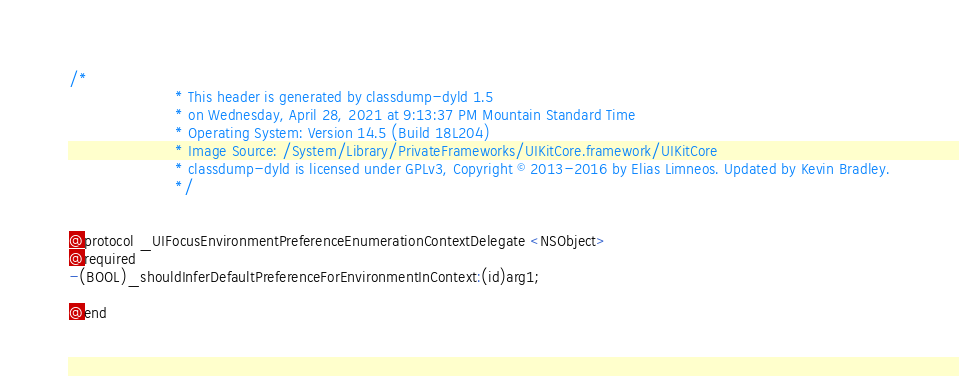<code> <loc_0><loc_0><loc_500><loc_500><_C_>/*
                       * This header is generated by classdump-dyld 1.5
                       * on Wednesday, April 28, 2021 at 9:13:37 PM Mountain Standard Time
                       * Operating System: Version 14.5 (Build 18L204)
                       * Image Source: /System/Library/PrivateFrameworks/UIKitCore.framework/UIKitCore
                       * classdump-dyld is licensed under GPLv3, Copyright © 2013-2016 by Elias Limneos. Updated by Kevin Bradley.
                       */


@protocol _UIFocusEnvironmentPreferenceEnumerationContextDelegate <NSObject>
@required
-(BOOL)_shouldInferDefaultPreferenceForEnvironmentInContext:(id)arg1;

@end

</code> 